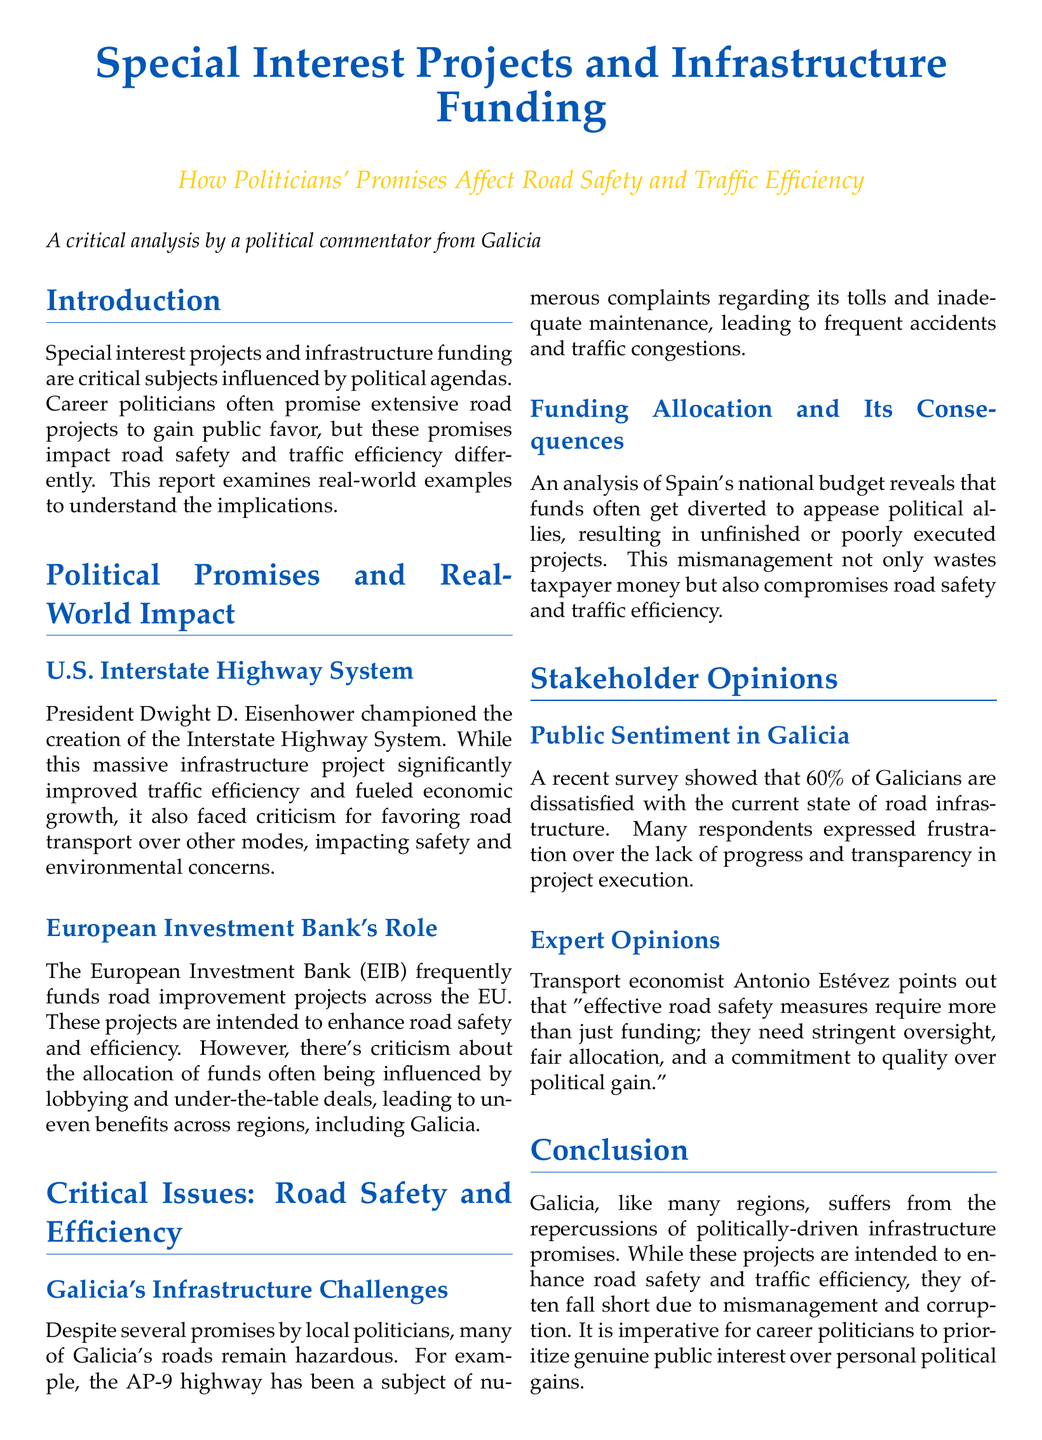What is the primary focus of the report? The report focuses on the impact of politicians' promises on road safety and traffic efficiency through special interest projects and infrastructure funding.
Answer: politicians' promises on road safety and traffic efficiency Who was the champion of the U.S. Interstate Highway System? The document specifies President Dwight D. Eisenhower as the champion of the U.S. Interstate Highway System.
Answer: President Dwight D. Eisenhower What percentage of Galicians are dissatisfied with the current state of road infrastructure? The report mentions that 60% of Galicians express dissatisfaction with the current state of road infrastructure.
Answer: 60% What is a major criticism regarding the European Investment Bank's role in funding? The criticism is that the allocation of funds is often influenced by lobbying and under-the-table deals.
Answer: lobbying and under-the-table deals Which highway in Galicia is noted for hazardous conditions? The AP-9 highway is highlighted as having hazardous conditions.
Answer: AP-9 highway What does transport economist Antonio Estévez emphasize as necessary for effective road safety measures? He emphasizes the need for stringent oversight, fair allocation, and a commitment to quality.
Answer: stringent oversight, fair allocation, and a commitment to quality What has been diverted from Spain's national budget, leading to project mismanagement? Funds have been diverted to appease political allies, resulting in project mismanagement.
Answer: Funds What is a significant result of mismanagement and corruption in infrastructure projects? It leads to compromised road safety and traffic efficiency.
Answer: compromised road safety and traffic efficiency What is the report's conclusion regarding political promises? The conclusion states that political promises often fall short due to mismanagement and corruption.
Answer: fall short due to mismanagement and corruption 